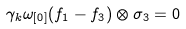Convert formula to latex. <formula><loc_0><loc_0><loc_500><loc_500>\gamma _ { k } \omega _ { [ 0 ] } ( f _ { 1 } - f _ { 3 } ) \otimes \sigma _ { 3 } = 0</formula> 